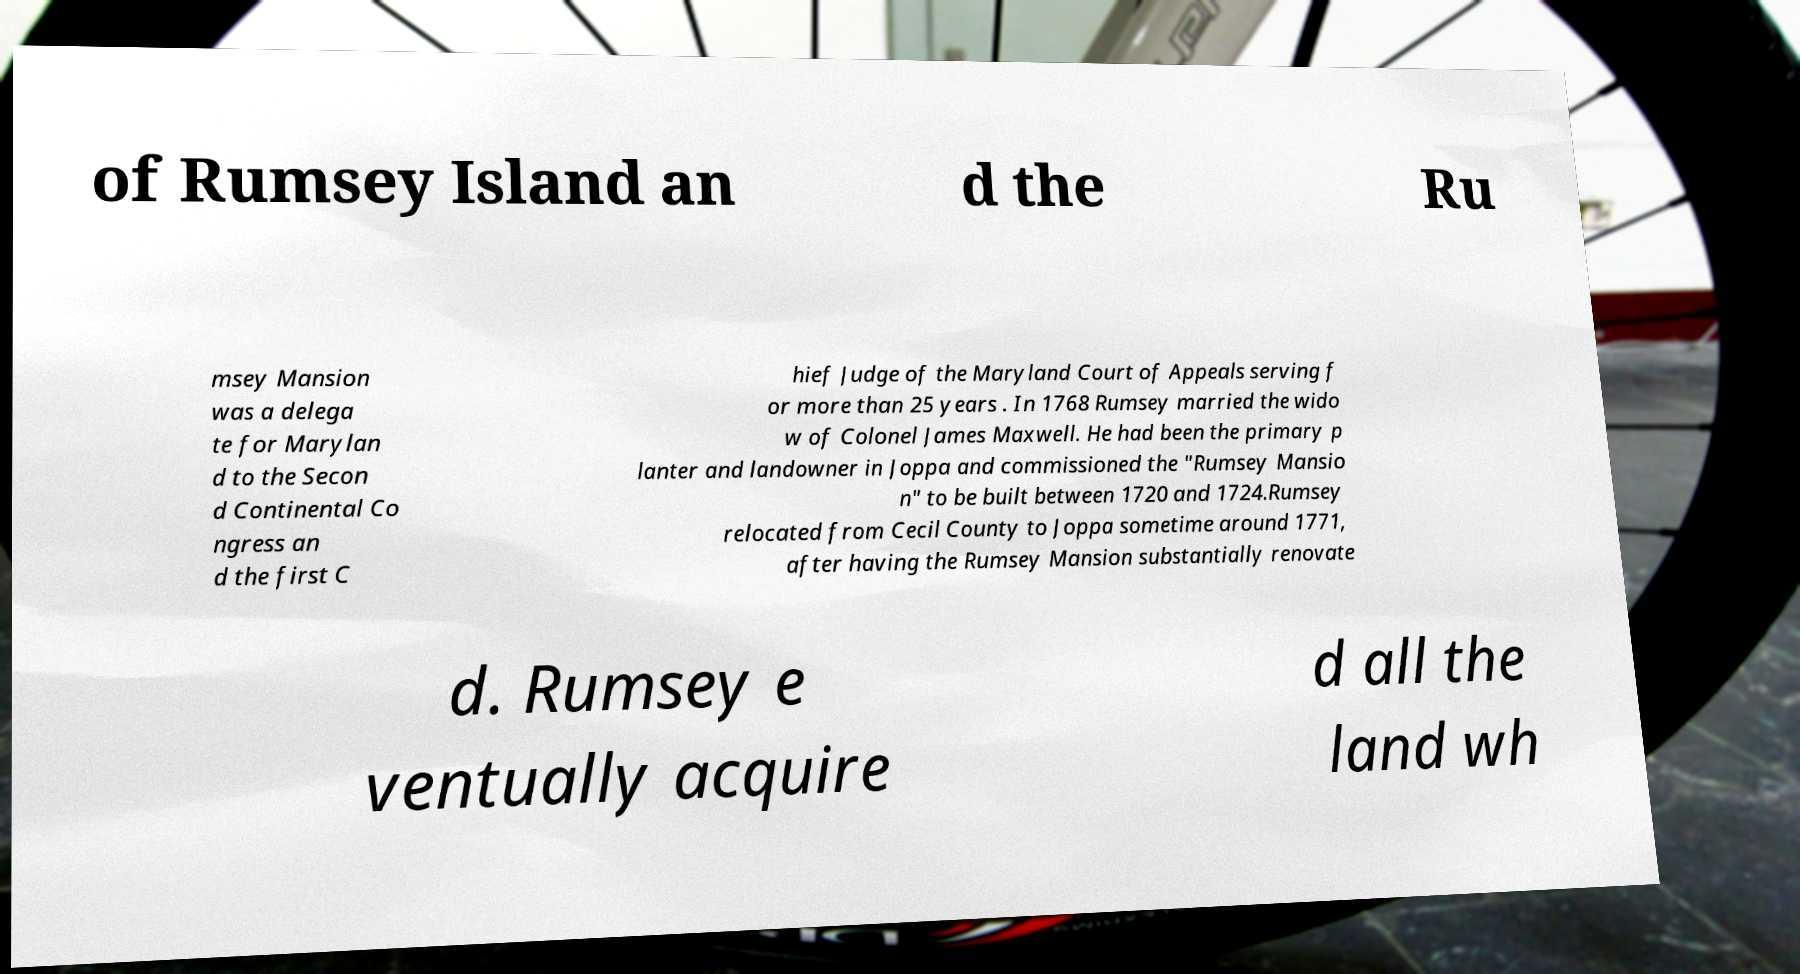For documentation purposes, I need the text within this image transcribed. Could you provide that? of Rumsey Island an d the Ru msey Mansion was a delega te for Marylan d to the Secon d Continental Co ngress an d the first C hief Judge of the Maryland Court of Appeals serving f or more than 25 years . In 1768 Rumsey married the wido w of Colonel James Maxwell. He had been the primary p lanter and landowner in Joppa and commissioned the "Rumsey Mansio n" to be built between 1720 and 1724.Rumsey relocated from Cecil County to Joppa sometime around 1771, after having the Rumsey Mansion substantially renovate d. Rumsey e ventually acquire d all the land wh 